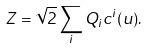<formula> <loc_0><loc_0><loc_500><loc_500>Z = \sqrt { 2 } \sum _ { i } Q _ { i } c ^ { i } ( u ) .</formula> 